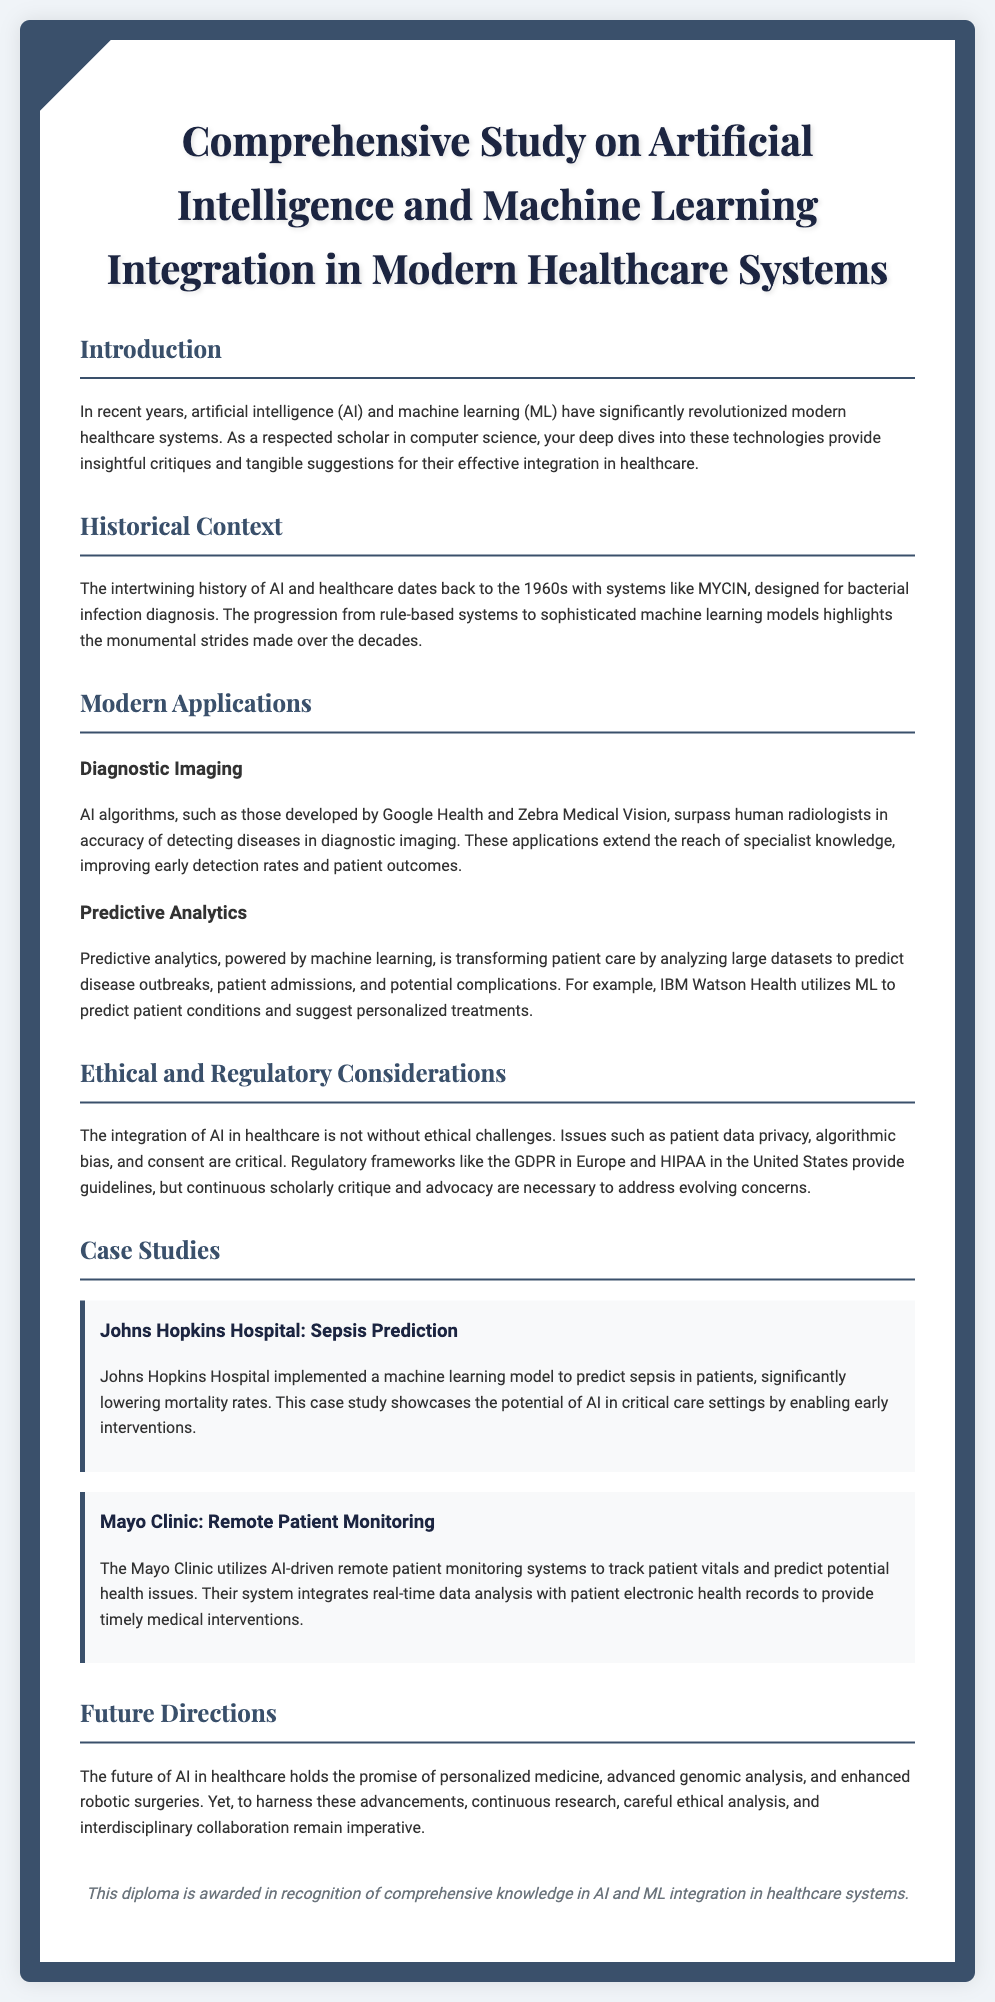What is the title of the diploma? The title is provided in the header of the document, summarizing the main focus of the study on AI and ML in healthcare.
Answer: Comprehensive Study on Artificial Intelligence and Machine Learning Integration in Modern Healthcare Systems When did the history of AI in healthcare begin? The document mentions the historical context of AI's integration into healthcare, pinpointing a specific decade.
Answer: 1960s What is one example of AI application in diagnostic imaging? The document lists specific applications developed by noted organizations in the field of diagnostic imaging.
Answer: Google Health Which healthcare institution implemented a model to predict sepsis? The case study section of the document details a specific case where a healthcare institution used an AI model effectively.
Answer: Johns Hopkins Hospital What is a significant ethical consideration mentioned? The document discusses various ethical implications related to AI in healthcare, highlighting one critical area.
Answer: Patient data privacy What future direction for AI in healthcare is mentioned? The document outlines prospective advancements and topics of interest in the field of AI in healthcare.
Answer: Personalized medicine Which regulatory framework is mentioned in connection with AI integration? The document provides information on regulatory considerations that guide ethical compliance in the context of healthcare AI applications.
Answer: GDPR How has the Mayo Clinic utilized AI? The document describes the specific use case of AI by the Mayo Clinic in their healthcare operations.
Answer: Remote patient monitoring What is the purpose of this diploma? The concluding section of the document explains the significance of the diploma in recognizing knowledge aspects.
Answer: Comprehensive knowledge in AI and ML integration in healthcare systems 